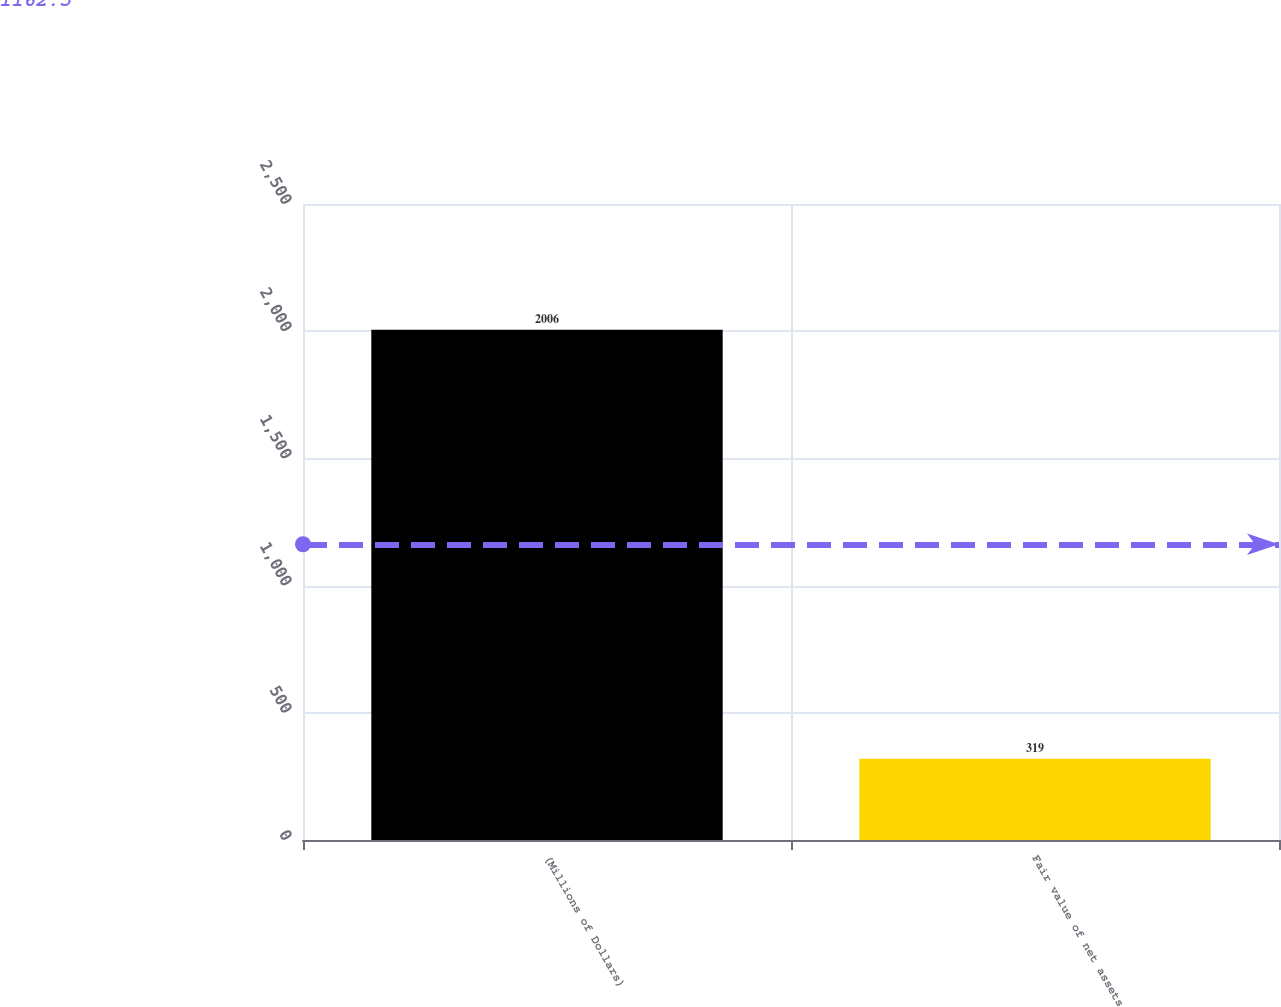Convert chart to OTSL. <chart><loc_0><loc_0><loc_500><loc_500><bar_chart><fcel>(Millions of Dollars)<fcel>Fair value of net assets<nl><fcel>2006<fcel>319<nl></chart> 